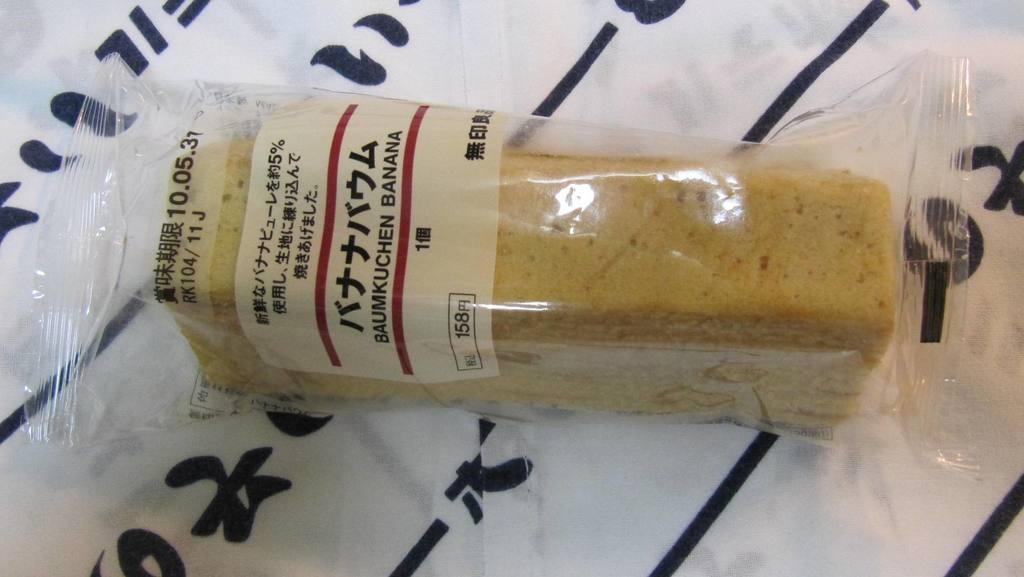Is the word "banana" on this product?
Your answer should be compact. Yes. 